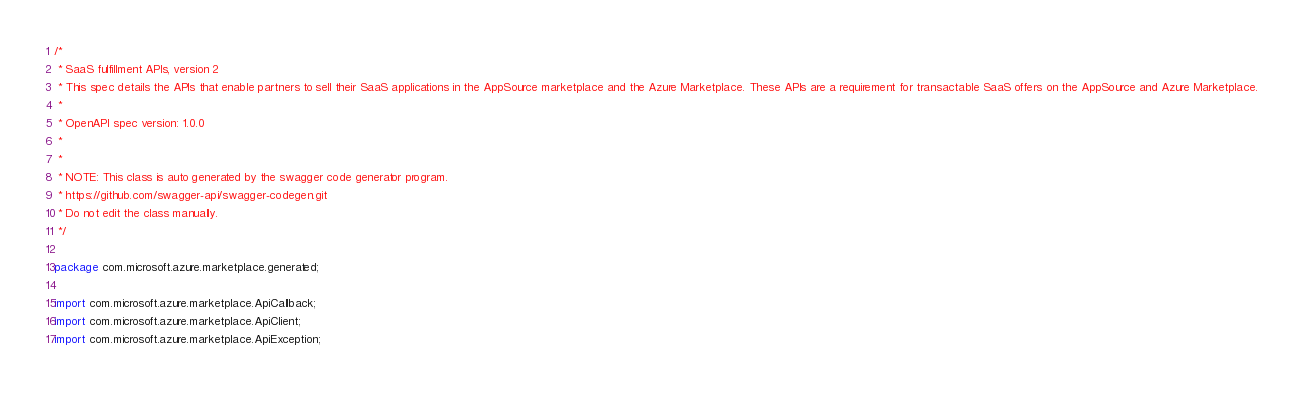Convert code to text. <code><loc_0><loc_0><loc_500><loc_500><_Java_>/*
 * SaaS fulfillment APIs, version 2
 * This spec details the APIs that enable partners to sell their SaaS applications in the AppSource marketplace and the Azure Marketplace. These APIs are a requirement for transactable SaaS offers on the AppSource and Azure Marketplace.
 *
 * OpenAPI spec version: 1.0.0
 * 
 *
 * NOTE: This class is auto generated by the swagger code generator program.
 * https://github.com/swagger-api/swagger-codegen.git
 * Do not edit the class manually.
 */

package com.microsoft.azure.marketplace.generated;

import com.microsoft.azure.marketplace.ApiCallback;
import com.microsoft.azure.marketplace.ApiClient;
import com.microsoft.azure.marketplace.ApiException;</code> 